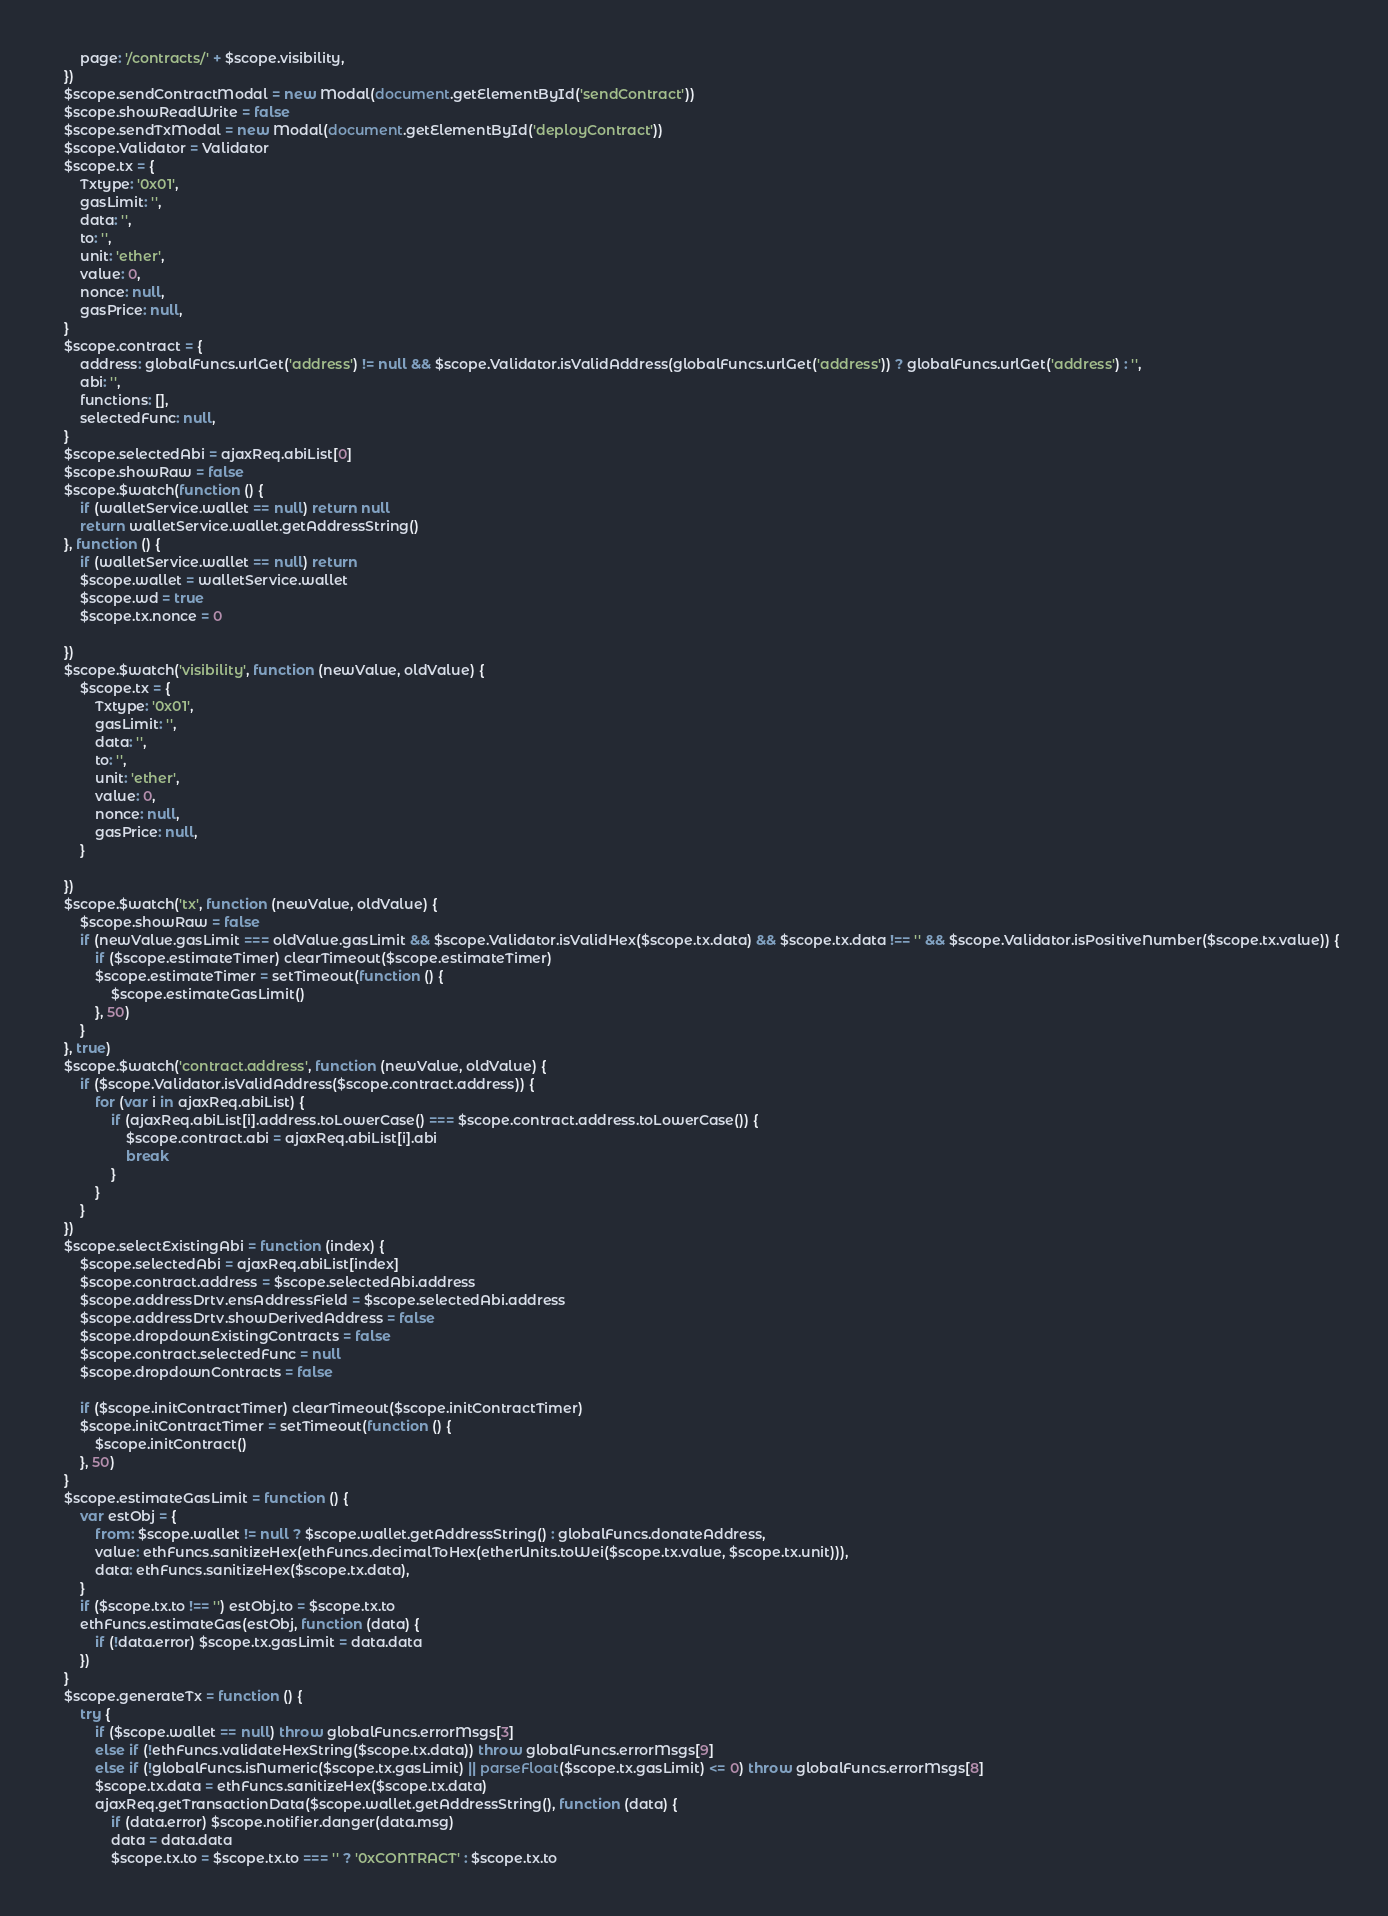<code> <loc_0><loc_0><loc_500><loc_500><_JavaScript_>        page: '/contracts/' + $scope.visibility,
    })
    $scope.sendContractModal = new Modal(document.getElementById('sendContract'))
    $scope.showReadWrite = false
    $scope.sendTxModal = new Modal(document.getElementById('deployContract'))
    $scope.Validator = Validator
    $scope.tx = {
        Txtype: '0x01',
        gasLimit: '',
        data: '',
        to: '',
        unit: 'ether',
        value: 0,
        nonce: null,
        gasPrice: null,
    }
    $scope.contract = {
        address: globalFuncs.urlGet('address') != null && $scope.Validator.isValidAddress(globalFuncs.urlGet('address')) ? globalFuncs.urlGet('address') : '',
        abi: '',
        functions: [],
        selectedFunc: null,
    }
    $scope.selectedAbi = ajaxReq.abiList[0]
    $scope.showRaw = false
    $scope.$watch(function () {
        if (walletService.wallet == null) return null
        return walletService.wallet.getAddressString()
    }, function () {
        if (walletService.wallet == null) return
        $scope.wallet = walletService.wallet
        $scope.wd = true
        $scope.tx.nonce = 0

    })
    $scope.$watch('visibility', function (newValue, oldValue) {
        $scope.tx = {
            Txtype: '0x01',
            gasLimit: '',
            data: '',
            to: '',
            unit: 'ether',
            value: 0,
            nonce: null,
            gasPrice: null,
        }

    })
    $scope.$watch('tx', function (newValue, oldValue) {
        $scope.showRaw = false
        if (newValue.gasLimit === oldValue.gasLimit && $scope.Validator.isValidHex($scope.tx.data) && $scope.tx.data !== '' && $scope.Validator.isPositiveNumber($scope.tx.value)) {
            if ($scope.estimateTimer) clearTimeout($scope.estimateTimer)
            $scope.estimateTimer = setTimeout(function () {
                $scope.estimateGasLimit()
            }, 50)
        }
    }, true)
    $scope.$watch('contract.address', function (newValue, oldValue) {
        if ($scope.Validator.isValidAddress($scope.contract.address)) {
            for (var i in ajaxReq.abiList) {
                if (ajaxReq.abiList[i].address.toLowerCase() === $scope.contract.address.toLowerCase()) {
                    $scope.contract.abi = ajaxReq.abiList[i].abi
                    break
                }
            }
        }
    })
    $scope.selectExistingAbi = function (index) {
        $scope.selectedAbi = ajaxReq.abiList[index]
        $scope.contract.address = $scope.selectedAbi.address
        $scope.addressDrtv.ensAddressField = $scope.selectedAbi.address
        $scope.addressDrtv.showDerivedAddress = false
        $scope.dropdownExistingContracts = false
        $scope.contract.selectedFunc = null
        $scope.dropdownContracts = false

        if ($scope.initContractTimer) clearTimeout($scope.initContractTimer)
        $scope.initContractTimer = setTimeout(function () {
            $scope.initContract()
        }, 50)
    }
    $scope.estimateGasLimit = function () {
        var estObj = {
            from: $scope.wallet != null ? $scope.wallet.getAddressString() : globalFuncs.donateAddress,
            value: ethFuncs.sanitizeHex(ethFuncs.decimalToHex(etherUnits.toWei($scope.tx.value, $scope.tx.unit))),
            data: ethFuncs.sanitizeHex($scope.tx.data),
        }
        if ($scope.tx.to !== '') estObj.to = $scope.tx.to
        ethFuncs.estimateGas(estObj, function (data) {
            if (!data.error) $scope.tx.gasLimit = data.data
        })
    }
    $scope.generateTx = function () {
        try {
            if ($scope.wallet == null) throw globalFuncs.errorMsgs[3]
            else if (!ethFuncs.validateHexString($scope.tx.data)) throw globalFuncs.errorMsgs[9]
            else if (!globalFuncs.isNumeric($scope.tx.gasLimit) || parseFloat($scope.tx.gasLimit) <= 0) throw globalFuncs.errorMsgs[8]
            $scope.tx.data = ethFuncs.sanitizeHex($scope.tx.data)
            ajaxReq.getTransactionData($scope.wallet.getAddressString(), function (data) {
                if (data.error) $scope.notifier.danger(data.msg)
                data = data.data
                $scope.tx.to = $scope.tx.to === '' ? '0xCONTRACT' : $scope.tx.to</code> 